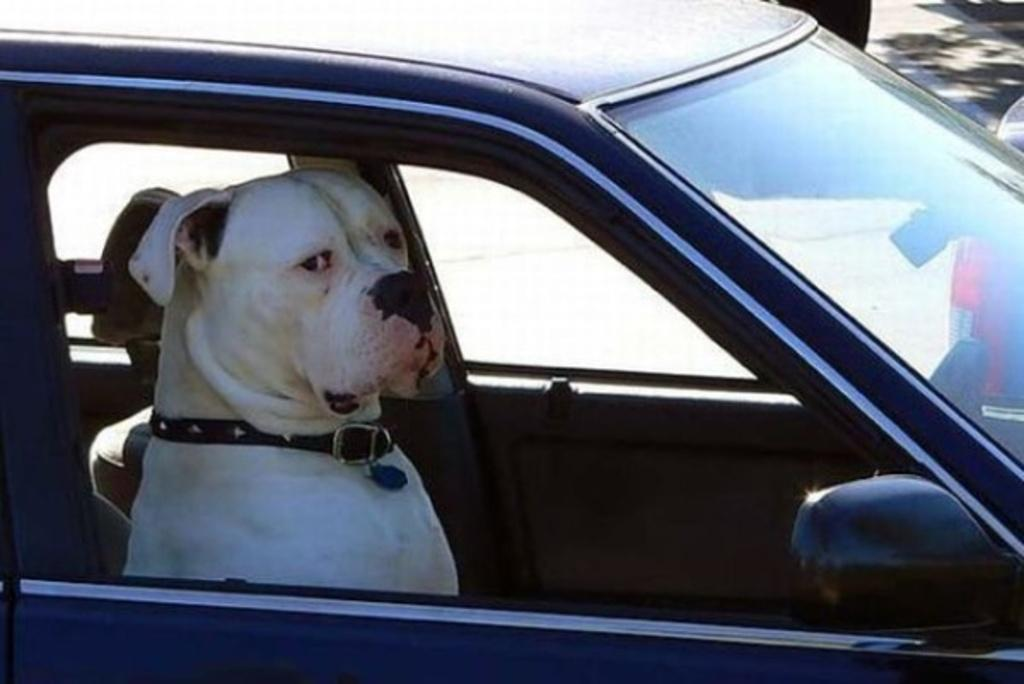What animal is present in the image? There is a dog in the image. Where is the dog located in the image? The dog is seated in a car. What is the dog wearing or holding in the image? There is a belt around the dog's neck. What type of mine can be seen in the image? There is no mine present in the image; it features a dog seated in a car with a belt around its neck. 